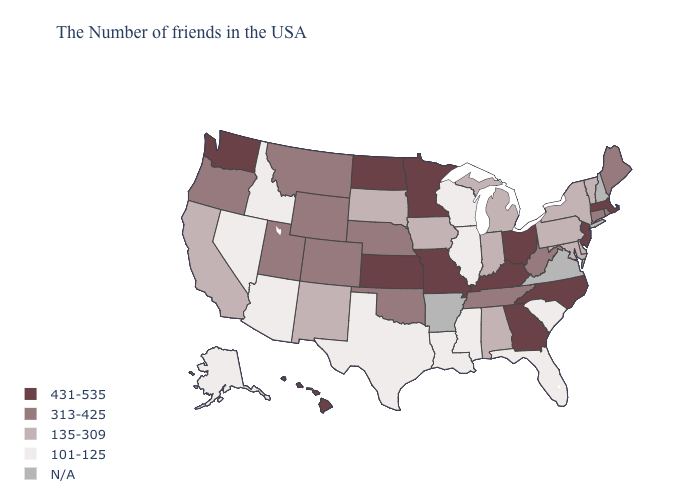What is the value of South Carolina?
Answer briefly. 101-125. Does Wisconsin have the lowest value in the MidWest?
Write a very short answer. Yes. Does New Jersey have the highest value in the USA?
Quick response, please. Yes. Does Ohio have the lowest value in the USA?
Give a very brief answer. No. Which states have the lowest value in the MidWest?
Quick response, please. Wisconsin, Illinois. Which states have the lowest value in the MidWest?
Give a very brief answer. Wisconsin, Illinois. Name the states that have a value in the range 101-125?
Concise answer only. South Carolina, Florida, Wisconsin, Illinois, Mississippi, Louisiana, Texas, Arizona, Idaho, Nevada, Alaska. What is the highest value in states that border North Dakota?
Quick response, please. 431-535. Name the states that have a value in the range 135-309?
Keep it brief. Vermont, New York, Delaware, Maryland, Pennsylvania, Michigan, Indiana, Alabama, Iowa, South Dakota, New Mexico, California. What is the value of Arizona?
Concise answer only. 101-125. Name the states that have a value in the range 313-425?
Write a very short answer. Maine, Rhode Island, Connecticut, West Virginia, Tennessee, Nebraska, Oklahoma, Wyoming, Colorado, Utah, Montana, Oregon. Does Mississippi have the highest value in the South?
Quick response, please. No. Among the states that border Idaho , which have the highest value?
Answer briefly. Washington. What is the value of Vermont?
Keep it brief. 135-309. Does Massachusetts have the highest value in the Northeast?
Short answer required. Yes. 